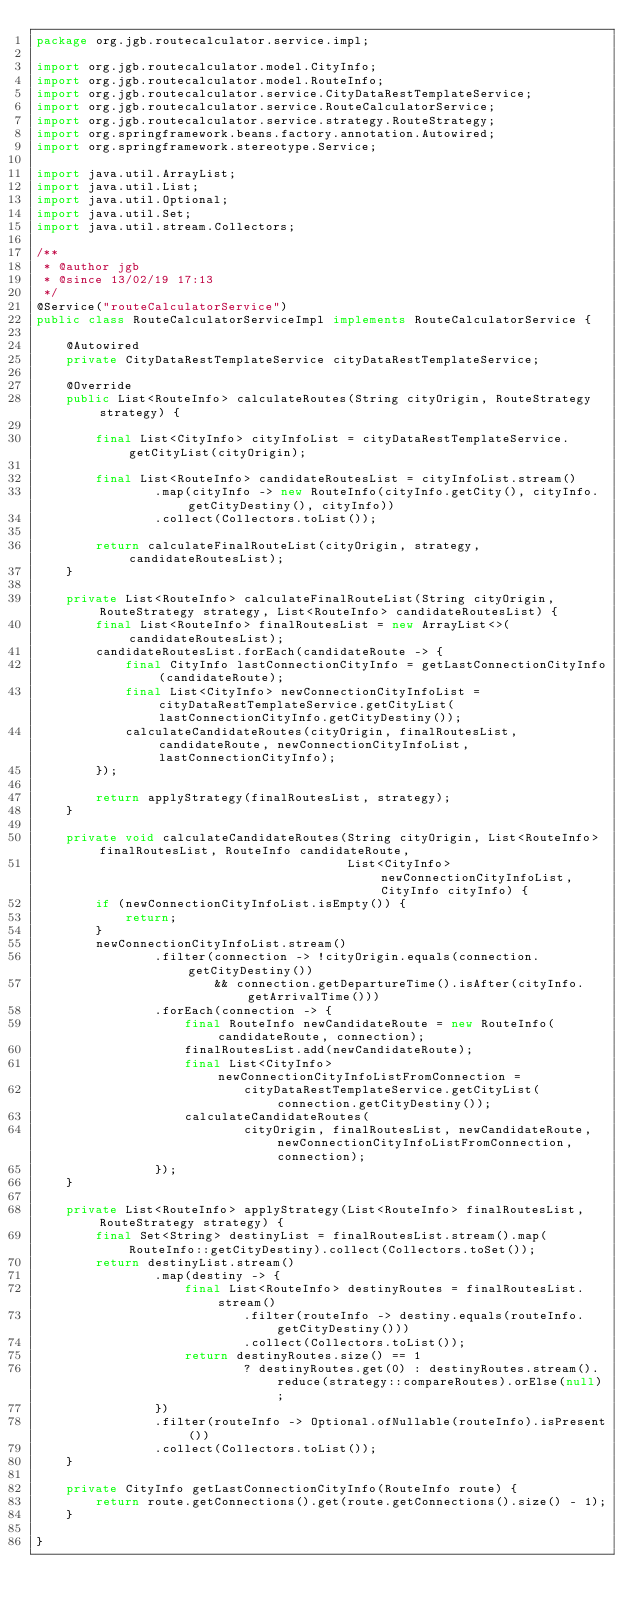Convert code to text. <code><loc_0><loc_0><loc_500><loc_500><_Java_>package org.jgb.routecalculator.service.impl;

import org.jgb.routecalculator.model.CityInfo;
import org.jgb.routecalculator.model.RouteInfo;
import org.jgb.routecalculator.service.CityDataRestTemplateService;
import org.jgb.routecalculator.service.RouteCalculatorService;
import org.jgb.routecalculator.service.strategy.RouteStrategy;
import org.springframework.beans.factory.annotation.Autowired;
import org.springframework.stereotype.Service;

import java.util.ArrayList;
import java.util.List;
import java.util.Optional;
import java.util.Set;
import java.util.stream.Collectors;

/**
 * @author jgb
 * @since 13/02/19 17:13
 */
@Service("routeCalculatorService")
public class RouteCalculatorServiceImpl implements RouteCalculatorService {

    @Autowired
    private CityDataRestTemplateService cityDataRestTemplateService;

    @Override
    public List<RouteInfo> calculateRoutes(String cityOrigin, RouteStrategy strategy) {

        final List<CityInfo> cityInfoList = cityDataRestTemplateService.getCityList(cityOrigin);

        final List<RouteInfo> candidateRoutesList = cityInfoList.stream()
                .map(cityInfo -> new RouteInfo(cityInfo.getCity(), cityInfo.getCityDestiny(), cityInfo))
                .collect(Collectors.toList());

        return calculateFinalRouteList(cityOrigin, strategy, candidateRoutesList);
    }

    private List<RouteInfo> calculateFinalRouteList(String cityOrigin, RouteStrategy strategy, List<RouteInfo> candidateRoutesList) {
        final List<RouteInfo> finalRoutesList = new ArrayList<>(candidateRoutesList);
        candidateRoutesList.forEach(candidateRoute -> {
            final CityInfo lastConnectionCityInfo = getLastConnectionCityInfo(candidateRoute);
            final List<CityInfo> newConnectionCityInfoList = cityDataRestTemplateService.getCityList(lastConnectionCityInfo.getCityDestiny());
            calculateCandidateRoutes(cityOrigin, finalRoutesList, candidateRoute, newConnectionCityInfoList, lastConnectionCityInfo);
        });

        return applyStrategy(finalRoutesList, strategy);
    }

    private void calculateCandidateRoutes(String cityOrigin, List<RouteInfo> finalRoutesList, RouteInfo candidateRoute,
                                          List<CityInfo> newConnectionCityInfoList, CityInfo cityInfo) {
        if (newConnectionCityInfoList.isEmpty()) {
            return;
        }
        newConnectionCityInfoList.stream()
                .filter(connection -> !cityOrigin.equals(connection.getCityDestiny())
                        && connection.getDepartureTime().isAfter(cityInfo.getArrivalTime()))
                .forEach(connection -> {
                    final RouteInfo newCandidateRoute = new RouteInfo(candidateRoute, connection);
                    finalRoutesList.add(newCandidateRoute);
                    final List<CityInfo> newConnectionCityInfoListFromConnection =
                            cityDataRestTemplateService.getCityList(connection.getCityDestiny());
                    calculateCandidateRoutes(
                            cityOrigin, finalRoutesList, newCandidateRoute, newConnectionCityInfoListFromConnection, connection);
                });
    }

    private List<RouteInfo> applyStrategy(List<RouteInfo> finalRoutesList, RouteStrategy strategy) {
        final Set<String> destinyList = finalRoutesList.stream().map(RouteInfo::getCityDestiny).collect(Collectors.toSet());
        return destinyList.stream()
                .map(destiny -> {
                    final List<RouteInfo> destinyRoutes = finalRoutesList.stream()
                            .filter(routeInfo -> destiny.equals(routeInfo.getCityDestiny()))
                            .collect(Collectors.toList());
                    return destinyRoutes.size() == 1
                            ? destinyRoutes.get(0) : destinyRoutes.stream().reduce(strategy::compareRoutes).orElse(null);
                })
                .filter(routeInfo -> Optional.ofNullable(routeInfo).isPresent())
                .collect(Collectors.toList());
    }

    private CityInfo getLastConnectionCityInfo(RouteInfo route) {
        return route.getConnections().get(route.getConnections().size() - 1);
    }

}
</code> 